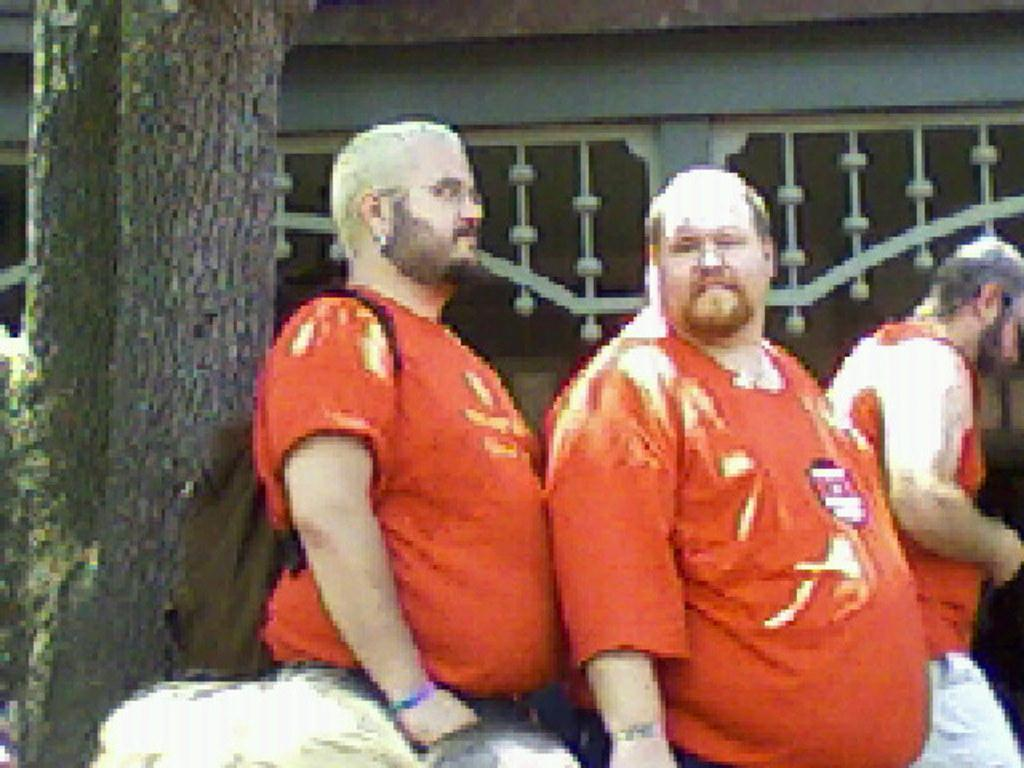How many people are present in the image? There are three persons in the image. What else can be seen in the image besides the people? There is a tree trunk and a building in the image. Can you describe the appearance of the image? The image appears to be edited. What type of volleyball game is being played in the image? There is no volleyball game present in the image. How many mice can be seen scurrying around in the image? There are no mice visible in the image. 